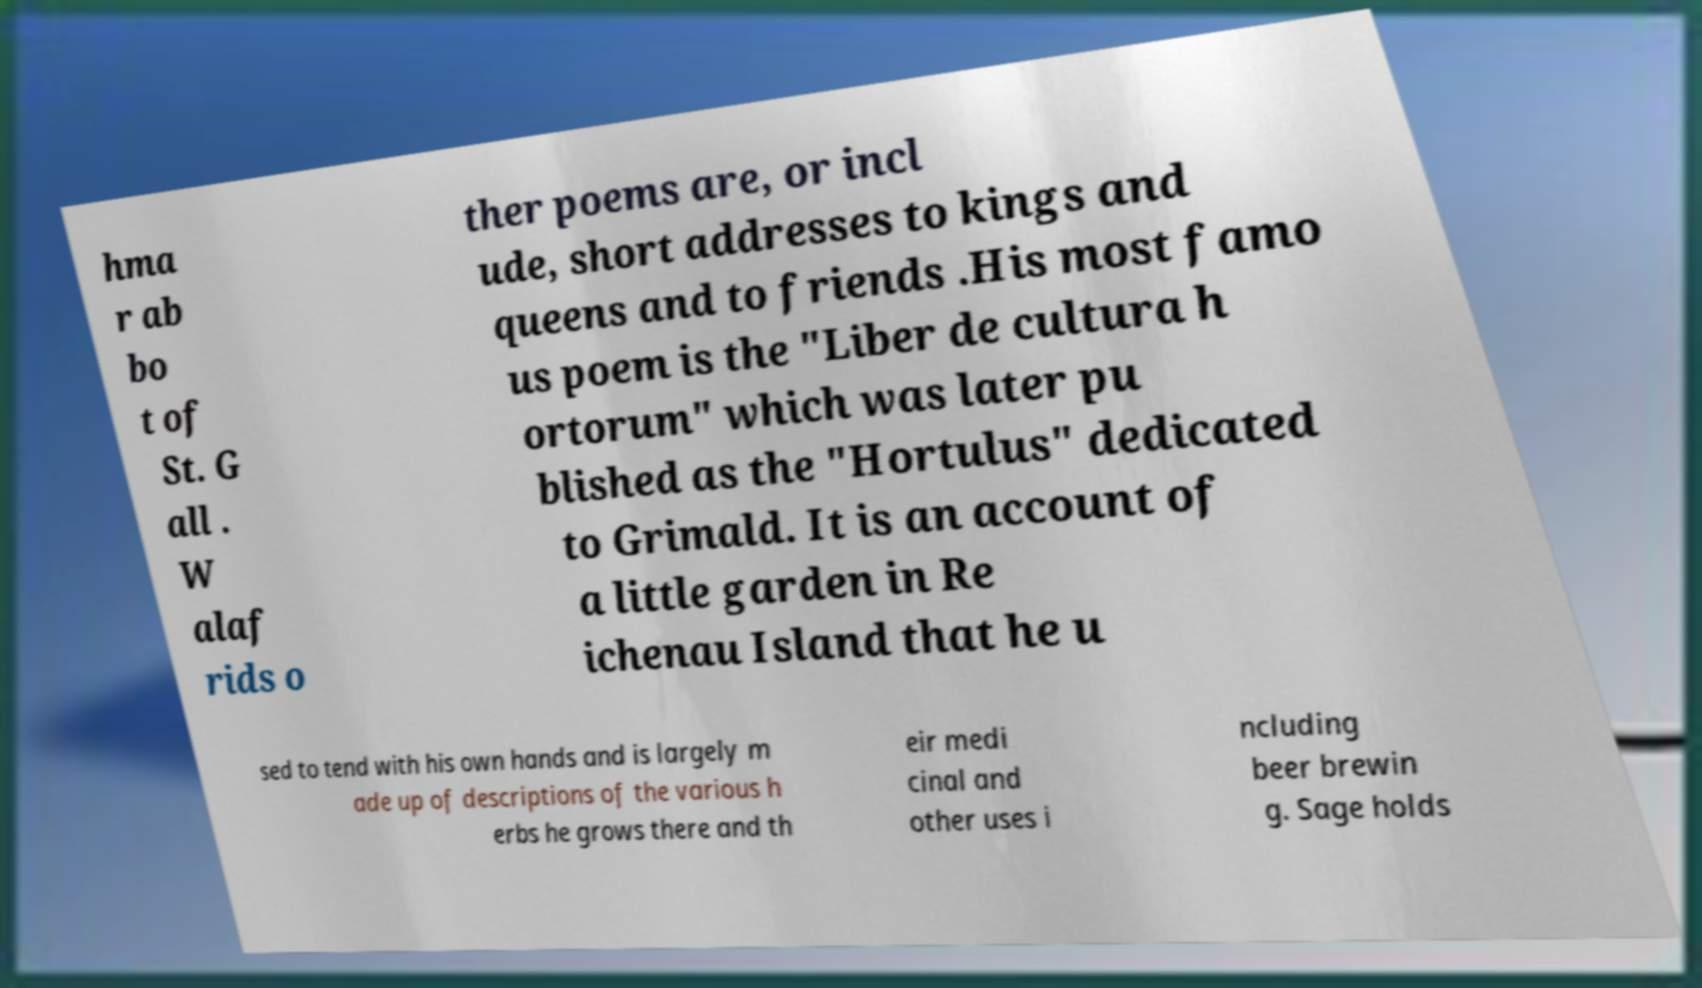Please read and relay the text visible in this image. What does it say? hma r ab bo t of St. G all . W alaf rids o ther poems are, or incl ude, short addresses to kings and queens and to friends .His most famo us poem is the "Liber de cultura h ortorum" which was later pu blished as the "Hortulus" dedicated to Grimald. It is an account of a little garden in Re ichenau Island that he u sed to tend with his own hands and is largely m ade up of descriptions of the various h erbs he grows there and th eir medi cinal and other uses i ncluding beer brewin g. Sage holds 